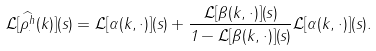Convert formula to latex. <formula><loc_0><loc_0><loc_500><loc_500>\mathcal { L } [ \widehat { \rho ^ { h } _ { \cdot } } ( k ) ] ( s ) = \mathcal { L } [ \alpha ( k , \cdot ) ] ( s ) + \frac { \mathcal { L } [ \beta ( k , \cdot ) ] ( s ) } { 1 - \mathcal { L } [ \beta ( k , \cdot ) ] ( s ) } \mathcal { L } [ \alpha ( k , \cdot ) ] ( s ) .</formula> 